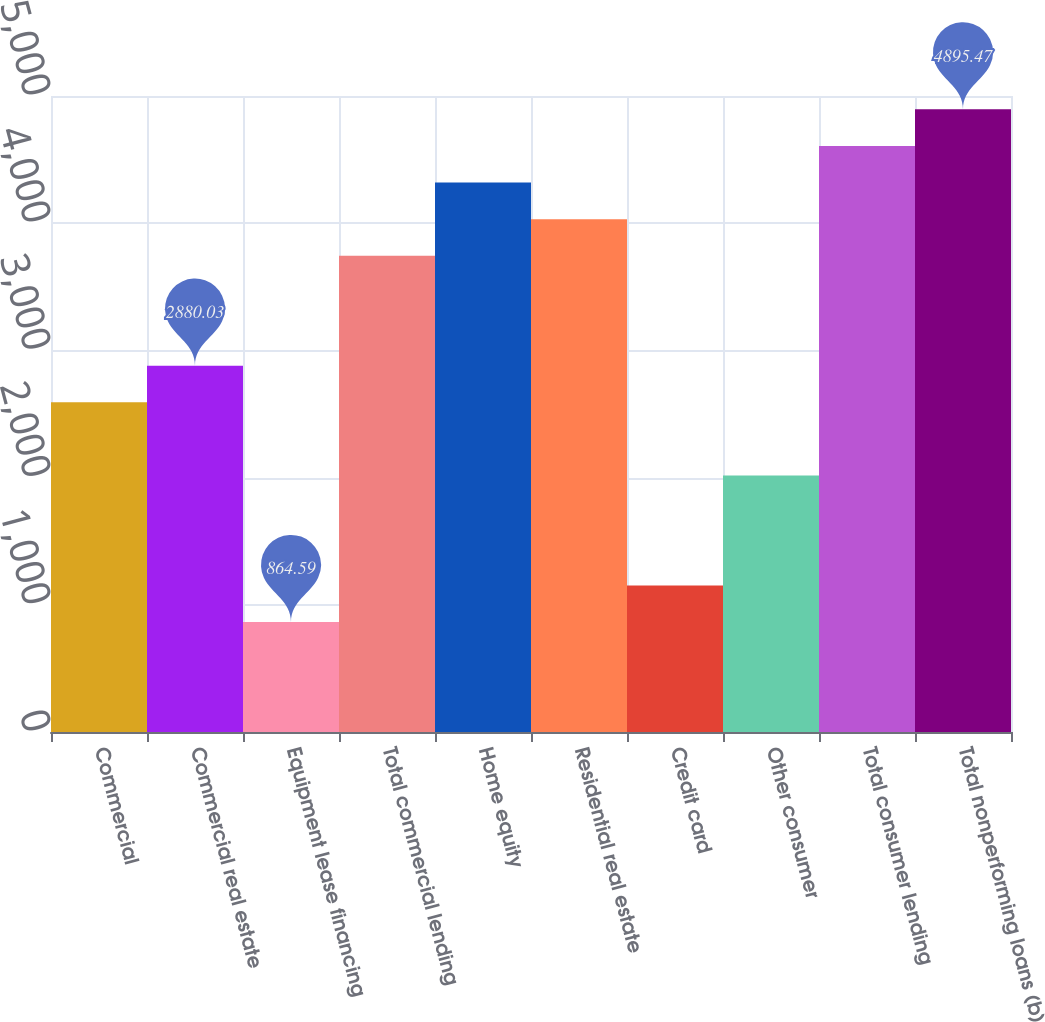Convert chart to OTSL. <chart><loc_0><loc_0><loc_500><loc_500><bar_chart><fcel>Commercial<fcel>Commercial real estate<fcel>Equipment lease financing<fcel>Total commercial lending<fcel>Home equity<fcel>Residential real estate<fcel>Credit card<fcel>Other consumer<fcel>Total consumer lending<fcel>Total nonperforming loans (b)<nl><fcel>2592.11<fcel>2880.03<fcel>864.59<fcel>3743.79<fcel>4319.63<fcel>4031.71<fcel>1152.51<fcel>2016.27<fcel>4607.55<fcel>4895.47<nl></chart> 